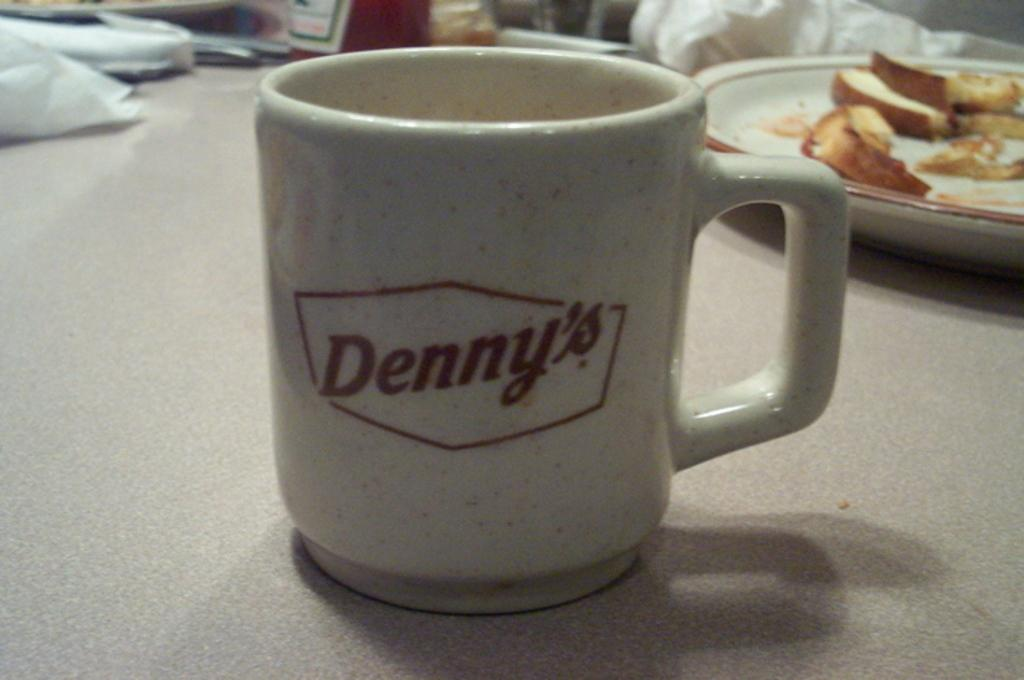<image>
Create a compact narrative representing the image presented. A Denny's mug sits on top of a table in a restaurant. 